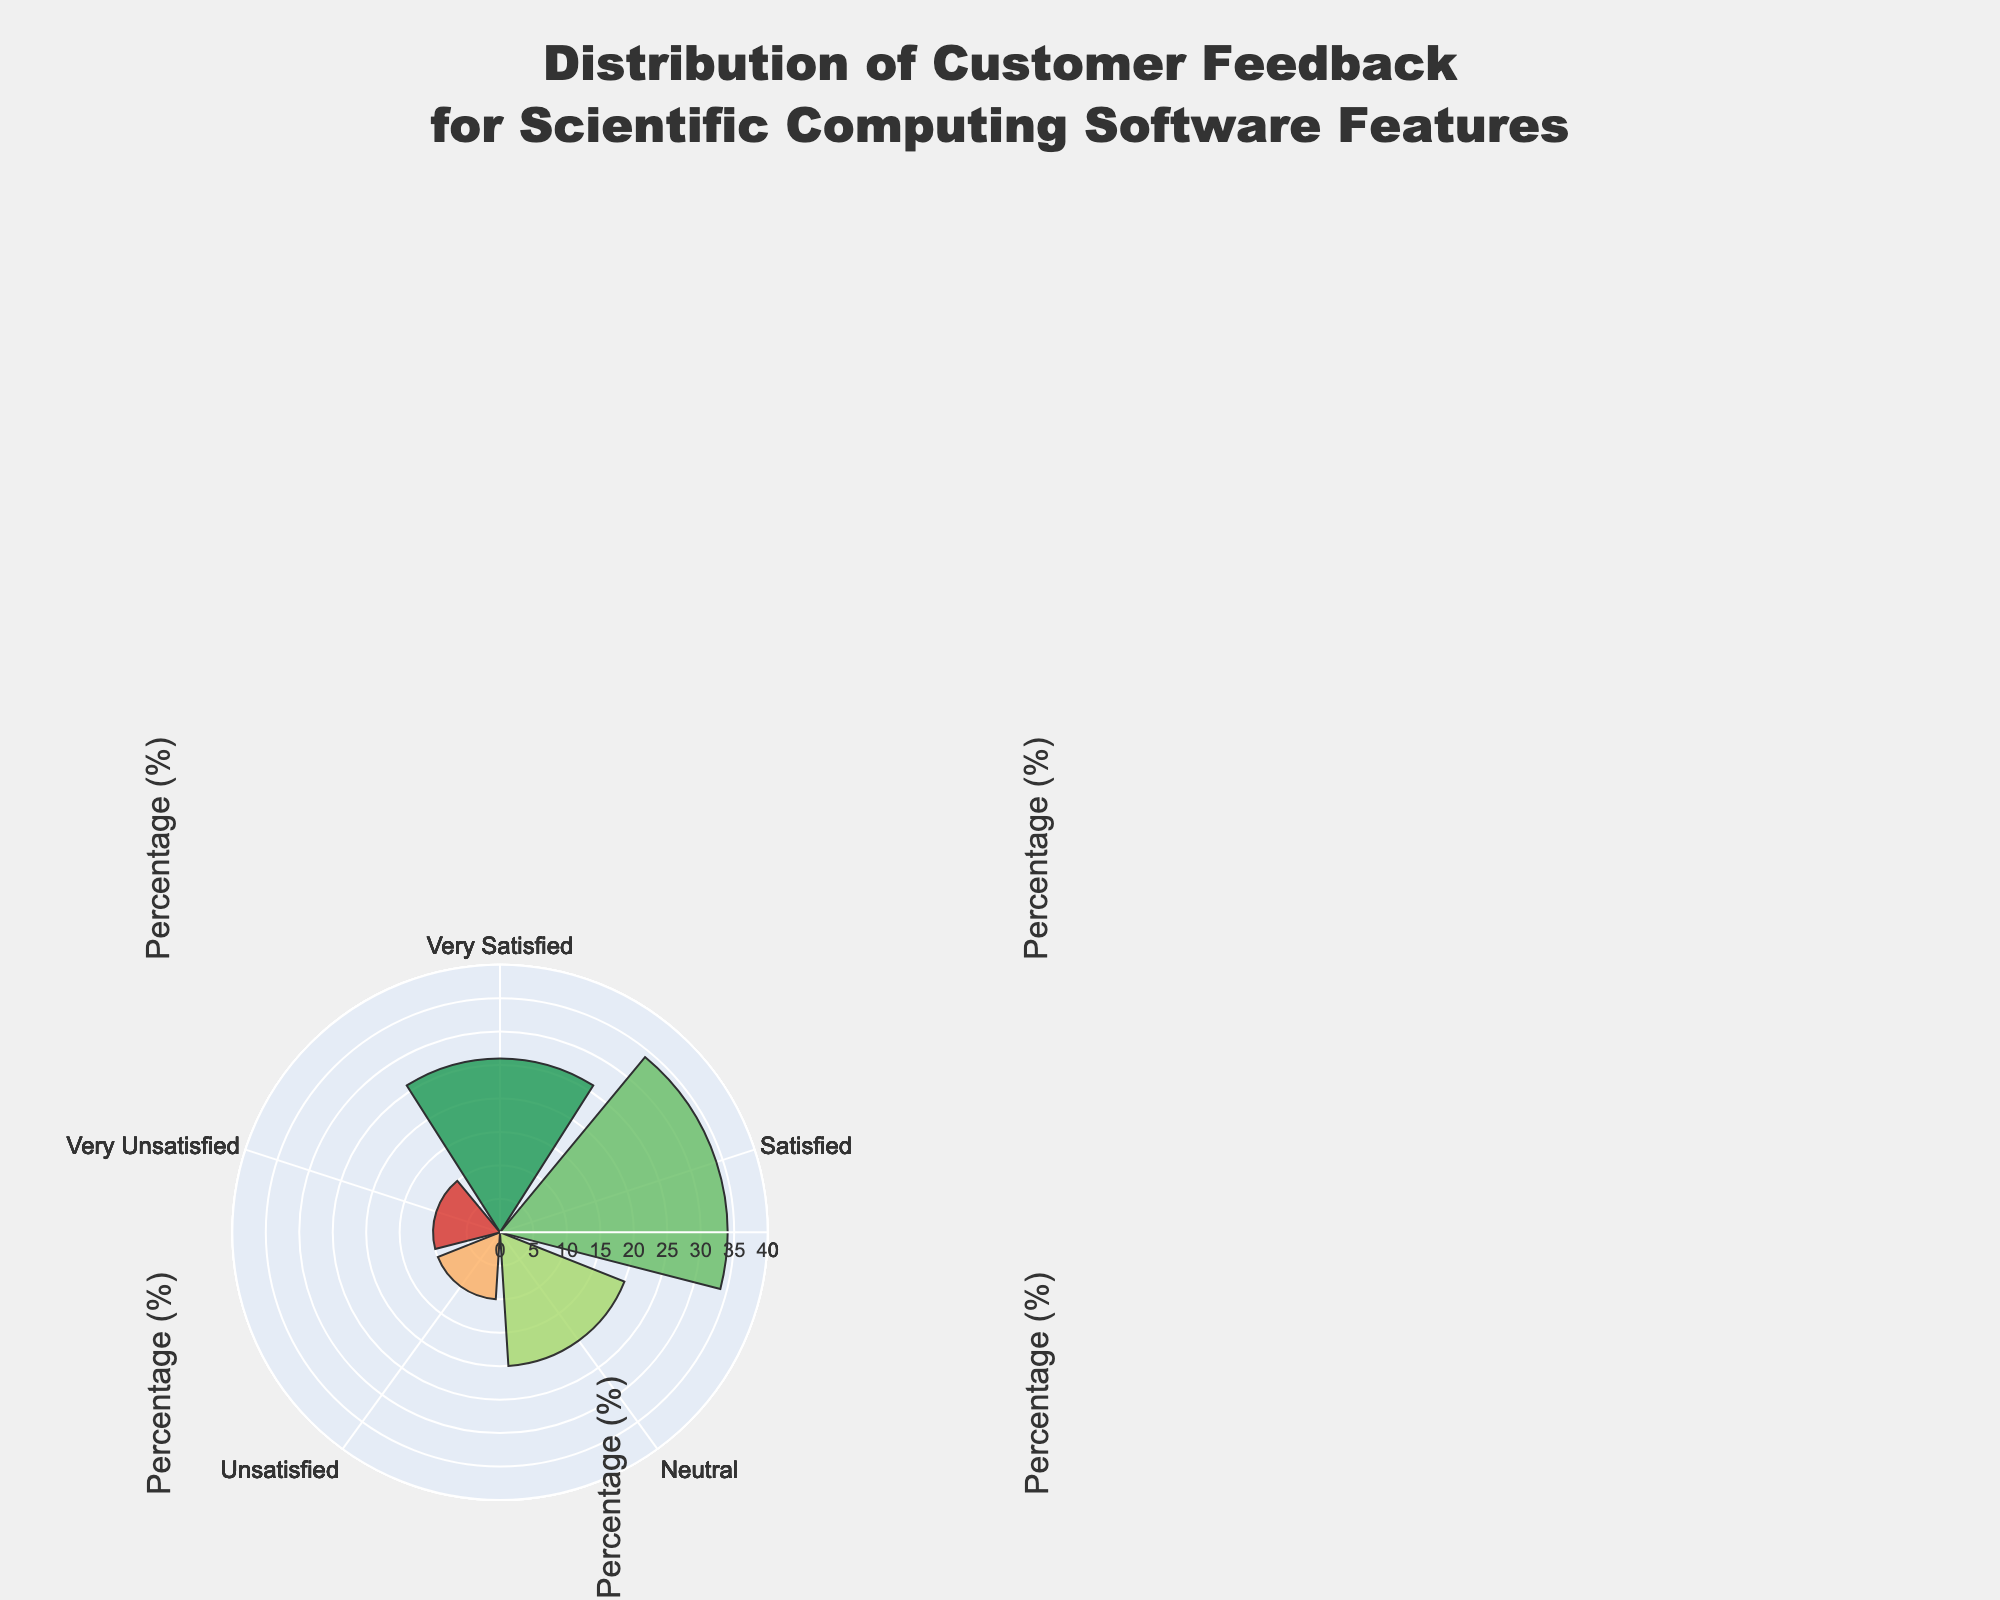What is the title of the figure? The title can be found at the top of the figure, giving an overview of what the chart represents. The title in this case is "Distribution of Customer Feedback for Scientific Computing Software Features".
Answer: Distribution of Customer Feedback for Scientific Computing Software Features Which feature has the highest percentage of "Very Satisfied" feedback? Review the data represented by each segment labeled "Very Satisfied" across all features and identify the one with the largest radial length. Performance has the highest percentage at 30%.
Answer: Performance What is the total percentage of "Satisfied" feedback for all features combined? Sum the individual percentages of "Satisfied" feedback for User Interface (35%), Performance (28%), Compatibility (30%), Documentation (32%), and Support Services (34%). The total is 35 + 28 + 30 + 32 + 34.
Answer: 159% Which feature has the lowest percentage of "Neutral" feedback? Check the portion of the radial bar labeled "Neutral" for each feature and identify the smallest one. Performance has the lowest percentage at 18%.
Answer: Performance Compare the "Unsatisfied" feedback percentages between User Interface and Documentation. Which is higher? Check the length of the radial bar labeled "Unsatisfied" for User Interface (12%) and Documentation (12%). They are equal.
Answer: Equal What is the average percentage of "Very Unsatisfied" feedback across all features? Sum the "Very Unsatisfied" feedback percentages for all features: User Interface (8%), Performance (9%), Compatibility (8%), Documentation (10%), and Support Services (10%). Then, divide by the number of features (5). (8 + 9 + 8 + 10 + 10) / 5 = 9.
Answer: 9% How does the percentage of "Satisfied" feedback for User Interface compare to Support Services? Look at the radial segments labeled "Satisfied" for both features. User Interface has 35% while Support Services has 34%. User Interface has a slightly higher percentage than Support Services.
Answer: User Interface is higher Which feature has the most varied feedback distribution, and why? Examine the spread of the percentages across different satisfaction levels for each feature. Documentation shows more dispersion with percentages ranging from 10% to 32%, compared to other features.
Answer: Documentation 